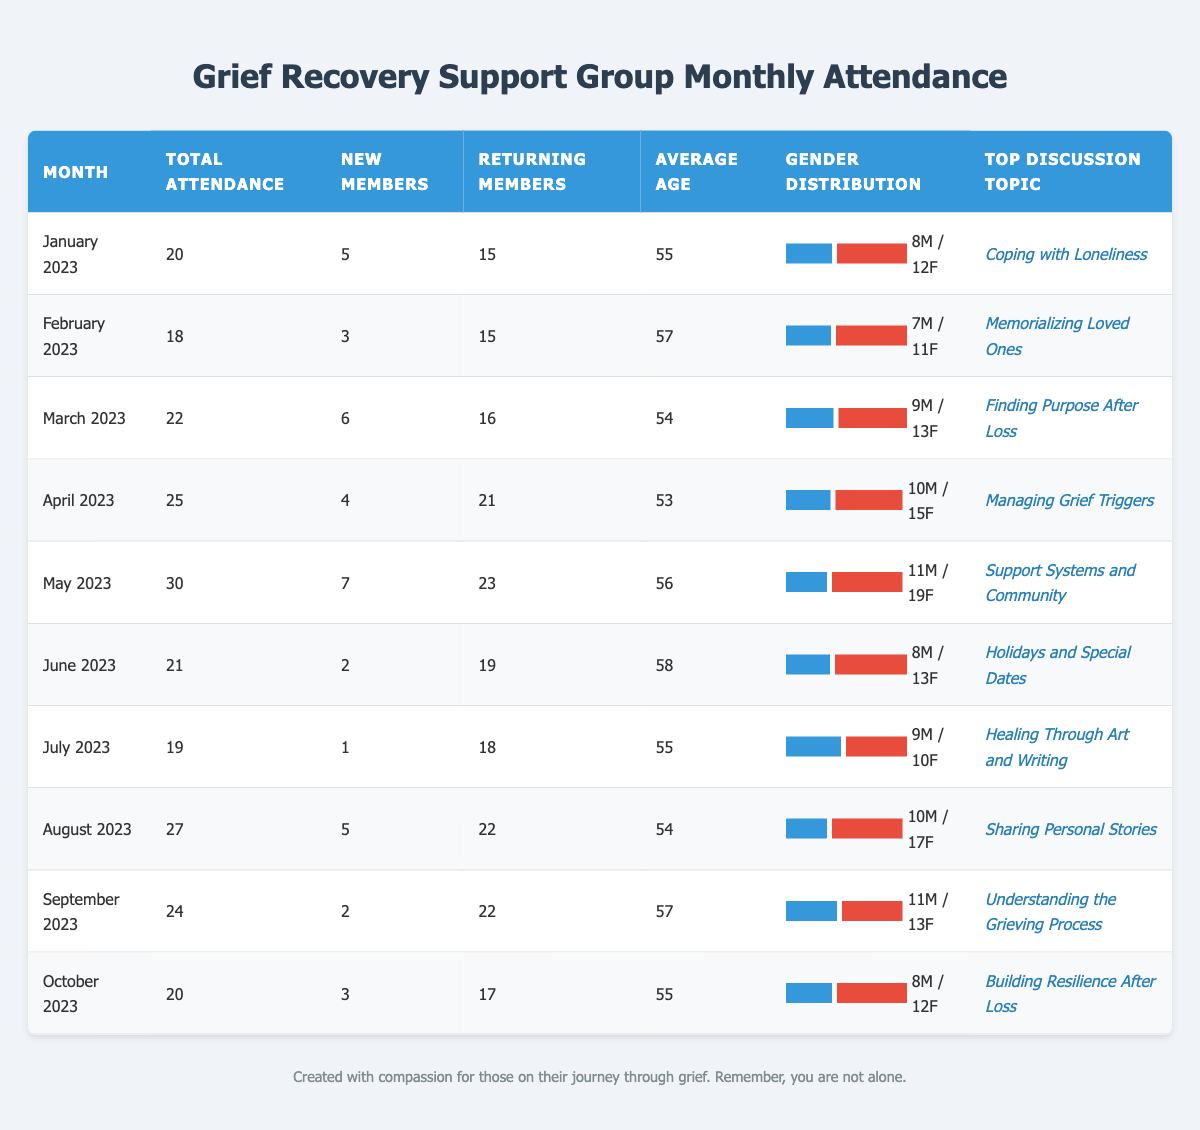what was the total attendance in May 2023? The table shows that the total attendance for May 2023 is listed directly under the Total Attendance column for that month. It states 30.
Answer: 30 how many new members joined the group in March 2023? Looking at the March 2023 row, the New Members column indicates that 6 new members joined during that month.
Answer: 6 what is the average age of attendees in April 2023? The Average Age column for April 2023 directly states that the average age of attendees is 53 years old.
Answer: 53 which month had the highest total attendance? By comparing the Total Attendance values for each month, May 2023 shows the highest number at 30, which is greater than any other month listed.
Answer: May 2023 what percentage of attendees in June 2023 were female? In June 2023, there were 21 total attendees, with 13 being female. To find the percentage, divide 13 by 21 and multiply by 100, which results in approximately 61.9%.
Answer: 61.9% did the number of new members decrease compared to the previous month in July 2023? In July 2023, the New Members count is 1, which is lower than 7 in June 2023. Therefore, the number of new members decreased.
Answer: Yes how many more returning members attended in August 2023 compared to July 2023? August 2023 had 22 returning members, while July 2023 had 18. To find the difference, subtract 18 from 22, which equals 4 more returning members in August.
Answer: 4 what is the trend in total attendance from January to October 2023? By reviewing the Total Attendance data for these months, you can notice fluctuations, with an overall increase until May, then a slight decrease followed by a re-increase in September. Summing it up, the trend shows variability.
Answer: Variable trend how does the gender distribution compare between January 2023 and October 2023? In January 2023, there were 12 females and 8 males, while in October 2023, there were again 12 females but 8 males. This shows no change in gender distribution between those two months.
Answer: No change which month had the top discussion topic related to understanding grief? The row for September 2023 indicates that the top discussion topic was "Understanding the Grieving Process," making it the relevant month for that topic.
Answer: September 2023 what is the total number of male attendees across all months? By adding the male attendees from each month: 8 + 7 + 9 + 10 + 11 + 8 + 9 + 10 + 11 + 8 = 81. Therefore, the total number of male attendees across all months is 81.
Answer: 81 how many months had an average age of 55 or older? Counting the months, January (55), February (57), April (53), May (56), June (58), September (57), October (55) all have average ages that meet or exceed 55, totaling 7 months.
Answer: 7 months 